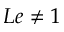<formula> <loc_0><loc_0><loc_500><loc_500>L e \neq 1</formula> 